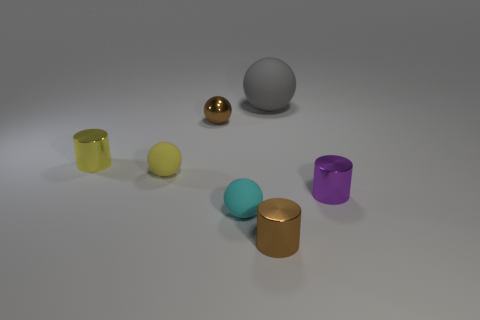Subtract all gray balls. How many balls are left? 3 Subtract all big spheres. How many spheres are left? 3 Subtract all green balls. Subtract all green cylinders. How many balls are left? 4 Add 1 metallic spheres. How many objects exist? 8 Subtract all spheres. How many objects are left? 3 Add 6 blue metal blocks. How many blue metal blocks exist? 6 Subtract 0 red balls. How many objects are left? 7 Subtract all big gray things. Subtract all matte balls. How many objects are left? 3 Add 5 shiny things. How many shiny things are left? 9 